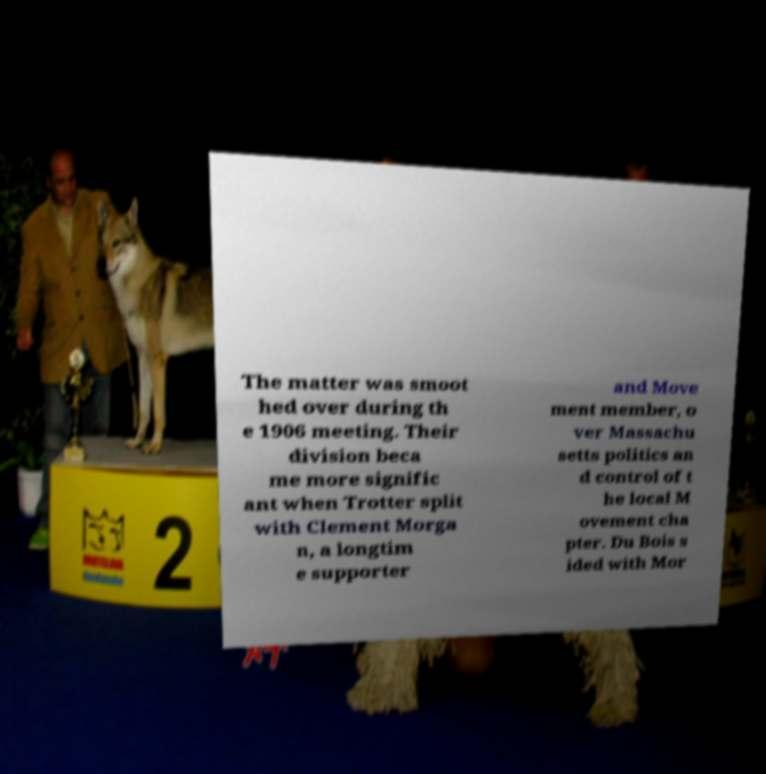There's text embedded in this image that I need extracted. Can you transcribe it verbatim? The matter was smoot hed over during th e 1906 meeting. Their division beca me more signific ant when Trotter split with Clement Morga n, a longtim e supporter and Move ment member, o ver Massachu setts politics an d control of t he local M ovement cha pter. Du Bois s ided with Mor 